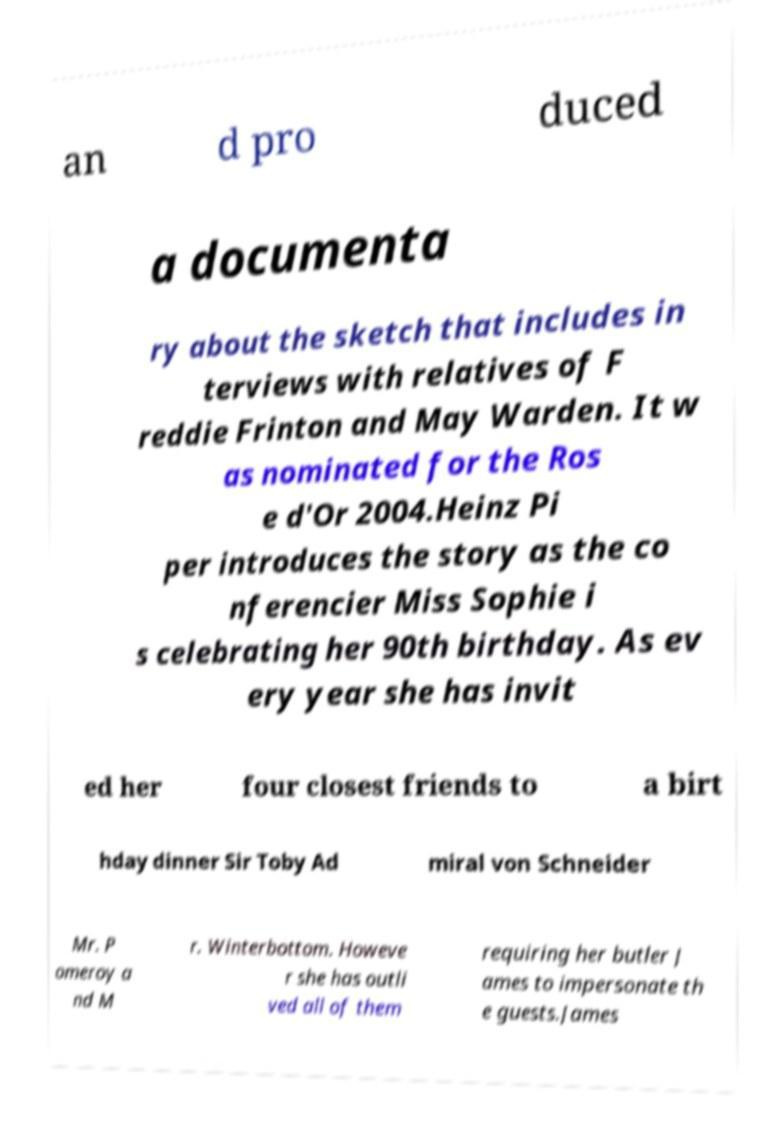For documentation purposes, I need the text within this image transcribed. Could you provide that? an d pro duced a documenta ry about the sketch that includes in terviews with relatives of F reddie Frinton and May Warden. It w as nominated for the Ros e d'Or 2004.Heinz Pi per introduces the story as the co nferencier Miss Sophie i s celebrating her 90th birthday. As ev ery year she has invit ed her four closest friends to a birt hday dinner Sir Toby Ad miral von Schneider Mr. P omeroy a nd M r. Winterbottom. Howeve r she has outli ved all of them requiring her butler J ames to impersonate th e guests.James 